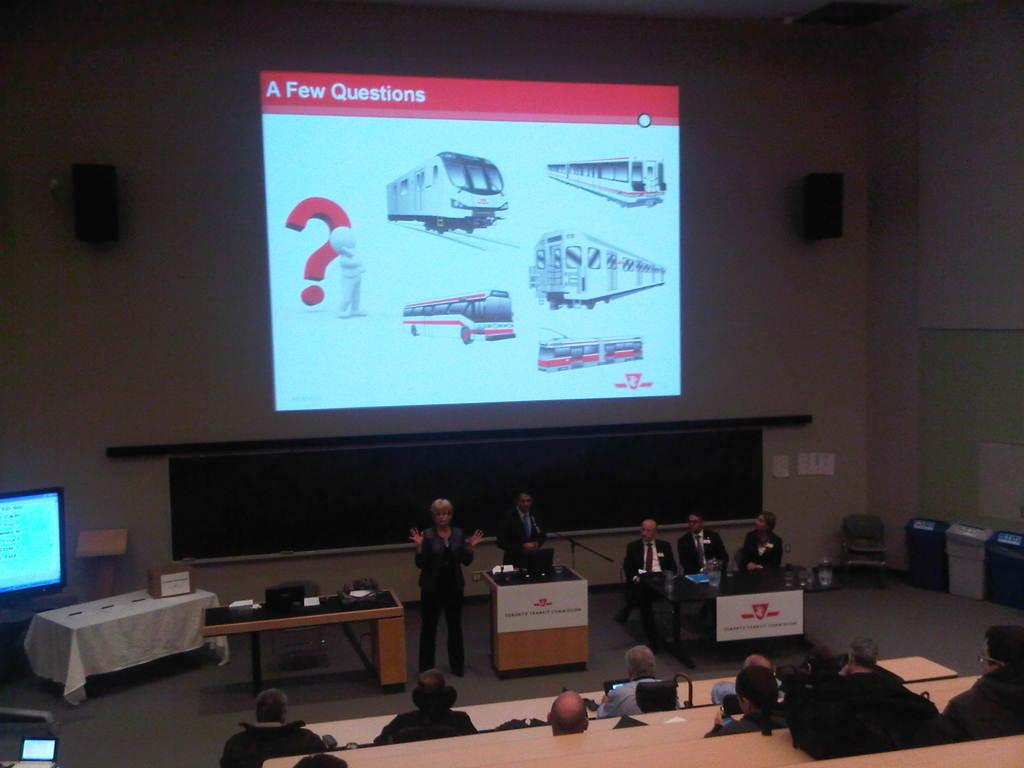<image>
Write a terse but informative summary of the picture. A large screen hangs above people with the words a few questions on the top. 